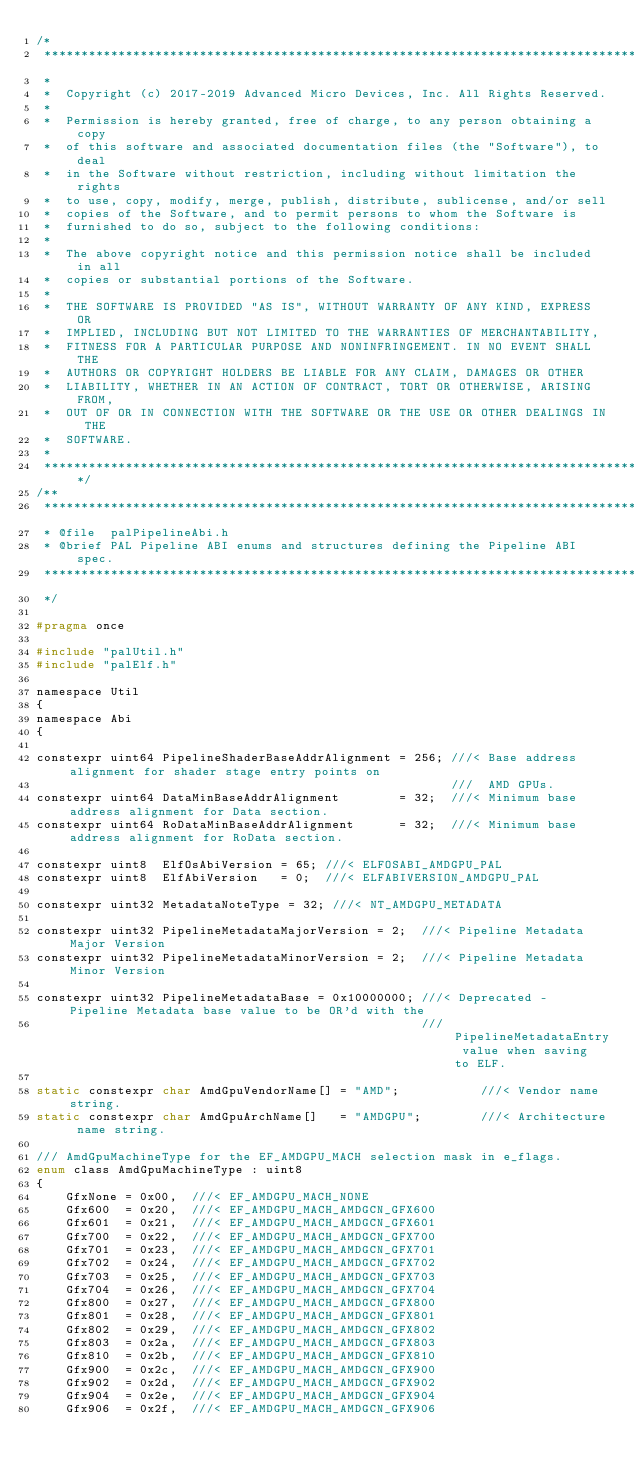Convert code to text. <code><loc_0><loc_0><loc_500><loc_500><_C_>/*
 ***********************************************************************************************************************
 *
 *  Copyright (c) 2017-2019 Advanced Micro Devices, Inc. All Rights Reserved.
 *
 *  Permission is hereby granted, free of charge, to any person obtaining a copy
 *  of this software and associated documentation files (the "Software"), to deal
 *  in the Software without restriction, including without limitation the rights
 *  to use, copy, modify, merge, publish, distribute, sublicense, and/or sell
 *  copies of the Software, and to permit persons to whom the Software is
 *  furnished to do so, subject to the following conditions:
 *
 *  The above copyright notice and this permission notice shall be included in all
 *  copies or substantial portions of the Software.
 *
 *  THE SOFTWARE IS PROVIDED "AS IS", WITHOUT WARRANTY OF ANY KIND, EXPRESS OR
 *  IMPLIED, INCLUDING BUT NOT LIMITED TO THE WARRANTIES OF MERCHANTABILITY,
 *  FITNESS FOR A PARTICULAR PURPOSE AND NONINFRINGEMENT. IN NO EVENT SHALL THE
 *  AUTHORS OR COPYRIGHT HOLDERS BE LIABLE FOR ANY CLAIM, DAMAGES OR OTHER
 *  LIABILITY, WHETHER IN AN ACTION OF CONTRACT, TORT OR OTHERWISE, ARISING FROM,
 *  OUT OF OR IN CONNECTION WITH THE SOFTWARE OR THE USE OR OTHER DEALINGS IN THE
 *  SOFTWARE.
 *
 **********************************************************************************************************************/
/**
 ***********************************************************************************************************************
 * @file  palPipelineAbi.h
 * @brief PAL Pipeline ABI enums and structures defining the Pipeline ABI spec.
 ***********************************************************************************************************************
 */

#pragma once

#include "palUtil.h"
#include "palElf.h"

namespace Util
{
namespace Abi
{

constexpr uint64 PipelineShaderBaseAddrAlignment = 256; ///< Base address alignment for shader stage entry points on
                                                        ///  AMD GPUs.
constexpr uint64 DataMinBaseAddrAlignment        = 32;  ///< Minimum base address alignment for Data section.
constexpr uint64 RoDataMinBaseAddrAlignment      = 32;  ///< Minimum base address alignment for RoData section.

constexpr uint8  ElfOsAbiVersion = 65; ///< ELFOSABI_AMDGPU_PAL
constexpr uint8  ElfAbiVersion   = 0;  ///< ELFABIVERSION_AMDGPU_PAL

constexpr uint32 MetadataNoteType = 32; ///< NT_AMDGPU_METADATA

constexpr uint32 PipelineMetadataMajorVersion = 2;  ///< Pipeline Metadata Major Version
constexpr uint32 PipelineMetadataMinorVersion = 2;  ///< Pipeline Metadata Minor Version

constexpr uint32 PipelineMetadataBase = 0x10000000; ///< Deprecated - Pipeline Metadata base value to be OR'd with the
                                                    ///  PipelineMetadataEntry value when saving to ELF.

static constexpr char AmdGpuVendorName[] = "AMD";           ///< Vendor name string.
static constexpr char AmdGpuArchName[]   = "AMDGPU";        ///< Architecture name string.

/// AmdGpuMachineType for the EF_AMDGPU_MACH selection mask in e_flags.
enum class AmdGpuMachineType : uint8
{
    GfxNone = 0x00,  ///< EF_AMDGPU_MACH_NONE
    Gfx600  = 0x20,  ///< EF_AMDGPU_MACH_AMDGCN_GFX600
    Gfx601  = 0x21,  ///< EF_AMDGPU_MACH_AMDGCN_GFX601
    Gfx700  = 0x22,  ///< EF_AMDGPU_MACH_AMDGCN_GFX700
    Gfx701  = 0x23,  ///< EF_AMDGPU_MACH_AMDGCN_GFX701
    Gfx702  = 0x24,  ///< EF_AMDGPU_MACH_AMDGCN_GFX702
    Gfx703  = 0x25,  ///< EF_AMDGPU_MACH_AMDGCN_GFX703
    Gfx704  = 0x26,  ///< EF_AMDGPU_MACH_AMDGCN_GFX704
    Gfx800  = 0x27,  ///< EF_AMDGPU_MACH_AMDGCN_GFX800
    Gfx801  = 0x28,  ///< EF_AMDGPU_MACH_AMDGCN_GFX801
    Gfx802  = 0x29,  ///< EF_AMDGPU_MACH_AMDGCN_GFX802
    Gfx803  = 0x2a,  ///< EF_AMDGPU_MACH_AMDGCN_GFX803
    Gfx810  = 0x2b,  ///< EF_AMDGPU_MACH_AMDGCN_GFX810
    Gfx900  = 0x2c,  ///< EF_AMDGPU_MACH_AMDGCN_GFX900
    Gfx902  = 0x2d,  ///< EF_AMDGPU_MACH_AMDGCN_GFX902
    Gfx904  = 0x2e,  ///< EF_AMDGPU_MACH_AMDGCN_GFX904
    Gfx906  = 0x2f,  ///< EF_AMDGPU_MACH_AMDGCN_GFX906</code> 